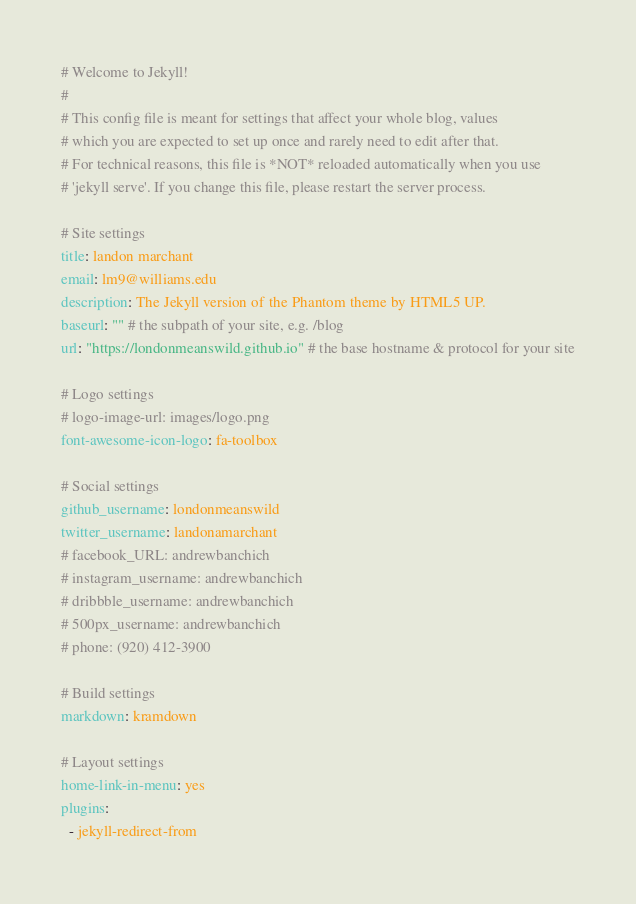<code> <loc_0><loc_0><loc_500><loc_500><_YAML_># Welcome to Jekyll!
#
# This config file is meant for settings that affect your whole blog, values
# which you are expected to set up once and rarely need to edit after that.
# For technical reasons, this file is *NOT* reloaded automatically when you use
# 'jekyll serve'. If you change this file, please restart the server process.

# Site settings
title: landon marchant
email: lm9@williams.edu
description: The Jekyll version of the Phantom theme by HTML5 UP.
baseurl: "" # the subpath of your site, e.g. /blog
url: "https://londonmeanswild.github.io" # the base hostname & protocol for your site

# Logo settings
# logo-image-url: images/logo.png
font-awesome-icon-logo: fa-toolbox

# Social settings
github_username: londonmeanswild
twitter_username: landonamarchant
# facebook_URL: andrewbanchich
# instagram_username: andrewbanchich
# dribbble_username: andrewbanchich
# 500px_username: andrewbanchich
# phone: (920) 412-3900

# Build settings
markdown: kramdown

# Layout settings
home-link-in-menu: yes
plugins:
  - jekyll-redirect-from
</code> 